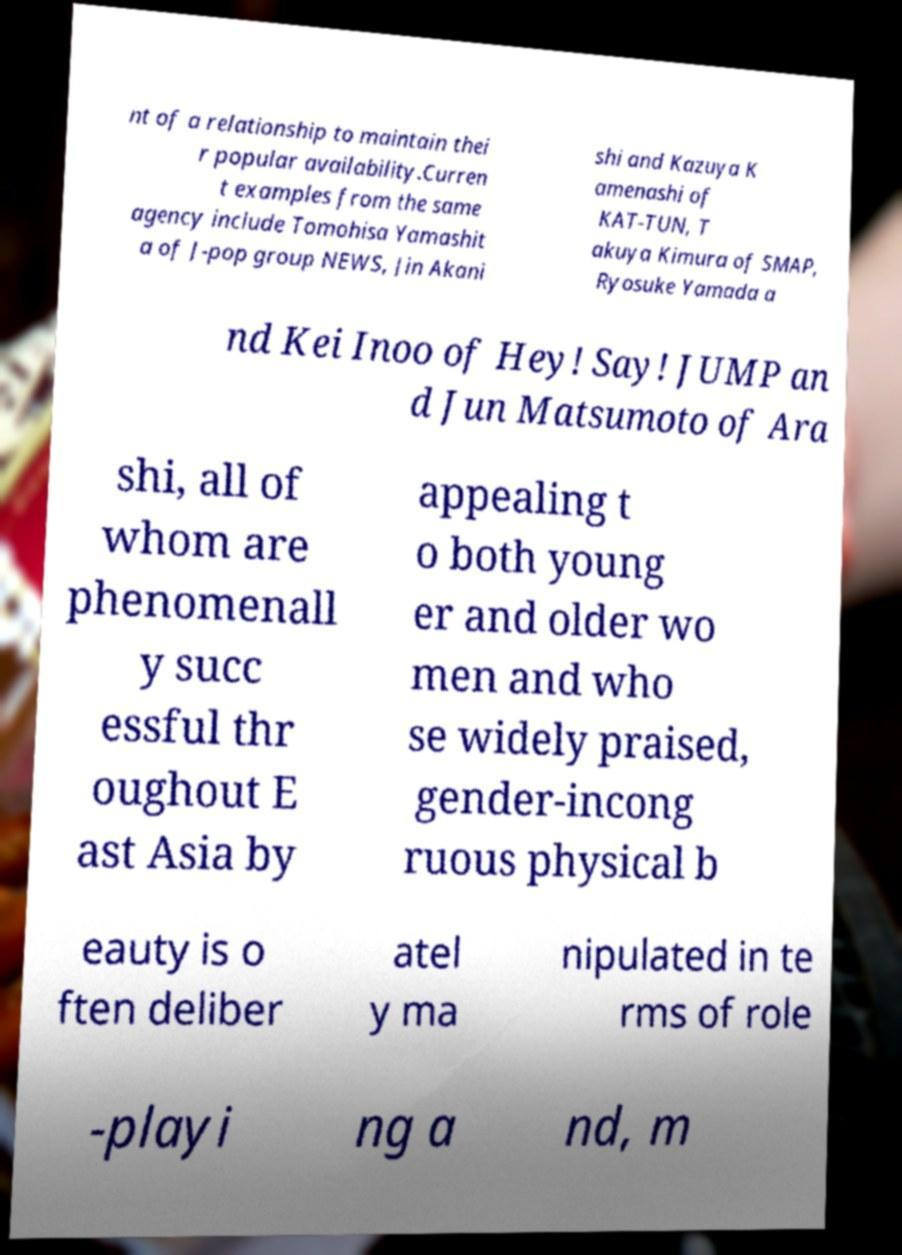I need the written content from this picture converted into text. Can you do that? nt of a relationship to maintain thei r popular availability.Curren t examples from the same agency include Tomohisa Yamashit a of J-pop group NEWS, Jin Akani shi and Kazuya K amenashi of KAT-TUN, T akuya Kimura of SMAP, Ryosuke Yamada a nd Kei Inoo of Hey! Say! JUMP an d Jun Matsumoto of Ara shi, all of whom are phenomenall y succ essful thr oughout E ast Asia by appealing t o both young er and older wo men and who se widely praised, gender-incong ruous physical b eauty is o ften deliber atel y ma nipulated in te rms of role -playi ng a nd, m 